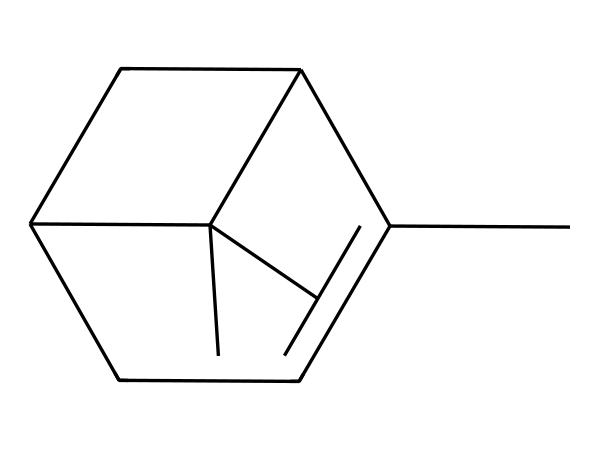How many carbon atoms are in the structure? By analyzing the SMILES representation, we can count each 'C' in the chemical structure, which represents carbon atoms. In this structure, there are 10 'C' characters.
Answer: 10 What is the molecular formula of this compound? Using the SMILES representation, we can infer the molecular formula by counting the number of carbon (C) and hydrogen (H) atoms. C is 10 and H is inferred to be 16. Therefore, the molecular formula is C10H16.
Answer: C10H16 Is this compound an isomer of limonene? Yes, pinene is an isomer of limonene as both have the same molecular formula (C10H16) but differ in structure. This is evident in the different arrangement of carbon atoms in their respective SMILES representations.
Answer: Yes What type of compound is pinene categorized as? Pinene is classified as a terpene due to its structure, which features a cycloalkane framework and multiple double bonds. This is a characteristic feature of terpenes.
Answer: terpene How many rings are present in the structure? The molecular structure shows two distinct ring formations as indicated by the connection pattern in the SMILES representation. By examining the structure, we can confirm the presence of two cyclical components.
Answer: 2 What is the characteristic smell associated with pinene? Pinene is known for its distinctive pine-like aroma, which is attributable to its structure as it is derived from pine trees and other resinous plants. This feature makes it recognizable and desirable in flavoring.
Answer: pine-like 